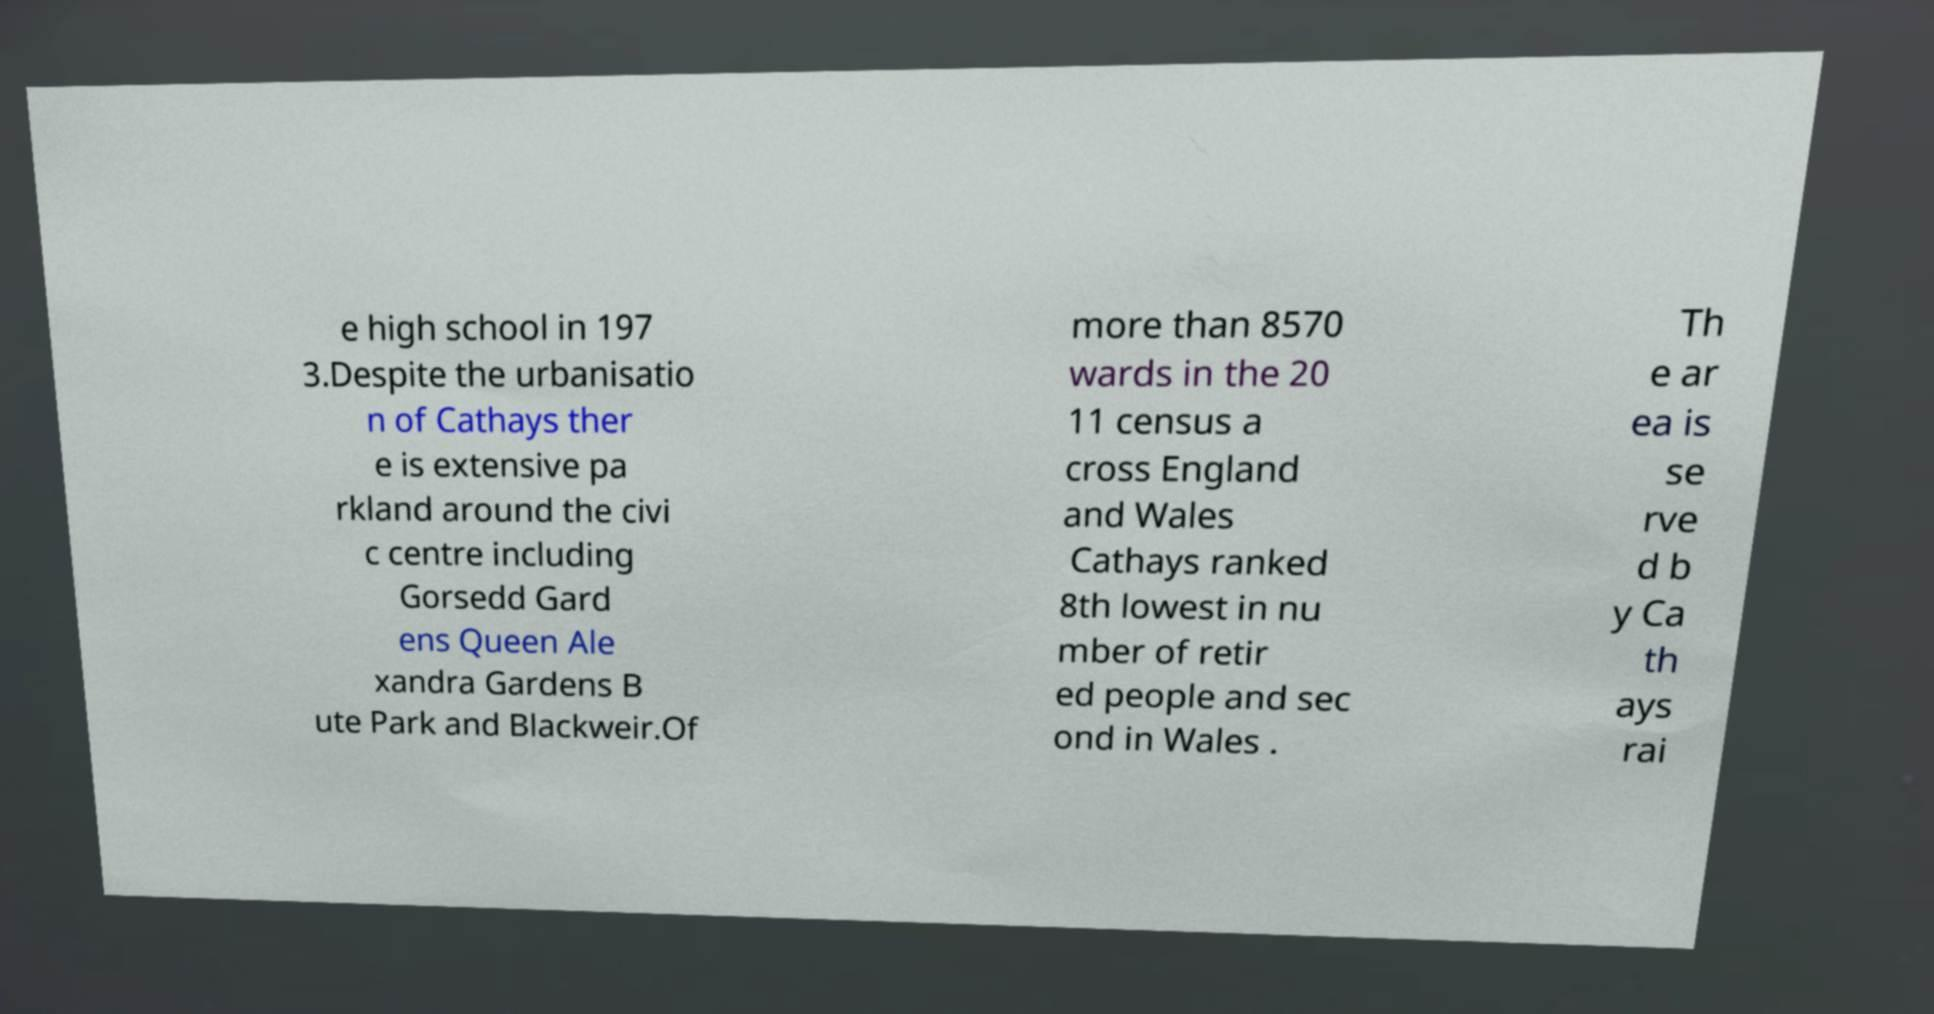I need the written content from this picture converted into text. Can you do that? e high school in 197 3.Despite the urbanisatio n of Cathays ther e is extensive pa rkland around the civi c centre including Gorsedd Gard ens Queen Ale xandra Gardens B ute Park and Blackweir.Of more than 8570 wards in the 20 11 census a cross England and Wales Cathays ranked 8th lowest in nu mber of retir ed people and sec ond in Wales . Th e ar ea is se rve d b y Ca th ays rai 